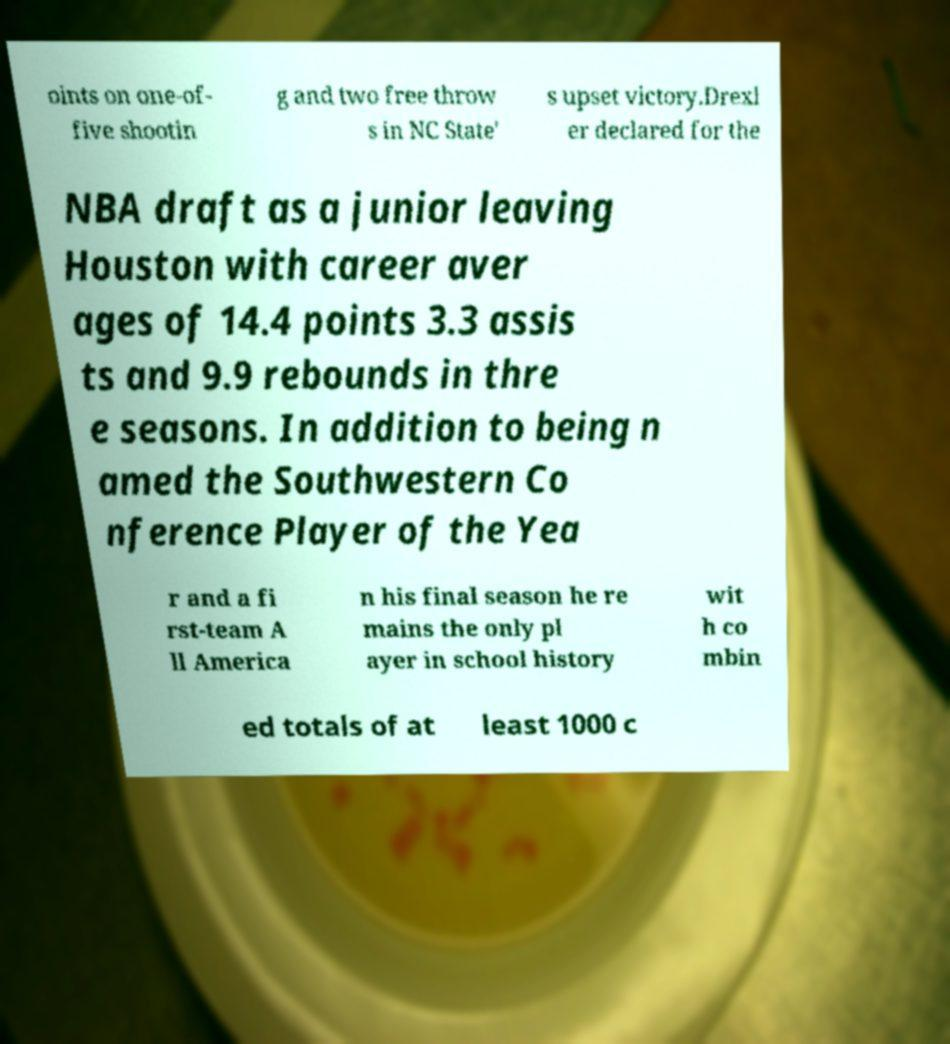For documentation purposes, I need the text within this image transcribed. Could you provide that? oints on one-of- five shootin g and two free throw s in NC State' s upset victory.Drexl er declared for the NBA draft as a junior leaving Houston with career aver ages of 14.4 points 3.3 assis ts and 9.9 rebounds in thre e seasons. In addition to being n amed the Southwestern Co nference Player of the Yea r and a fi rst-team A ll America n his final season he re mains the only pl ayer in school history wit h co mbin ed totals of at least 1000 c 